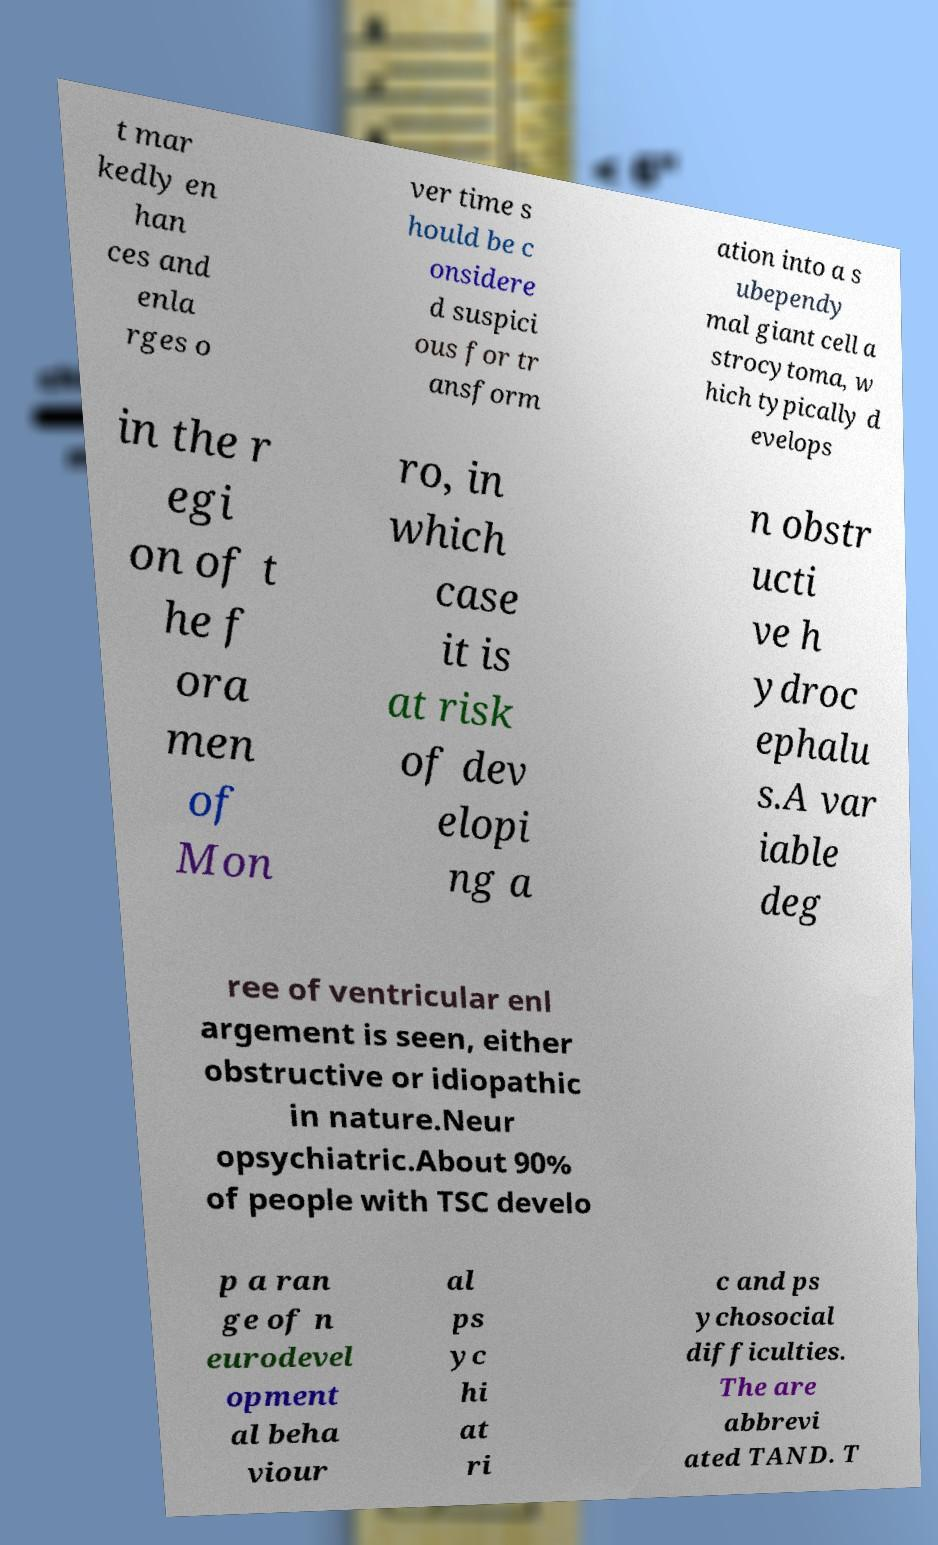Can you read and provide the text displayed in the image?This photo seems to have some interesting text. Can you extract and type it out for me? t mar kedly en han ces and enla rges o ver time s hould be c onsidere d suspici ous for tr ansform ation into a s ubependy mal giant cell a strocytoma, w hich typically d evelops in the r egi on of t he f ora men of Mon ro, in which case it is at risk of dev elopi ng a n obstr ucti ve h ydroc ephalu s.A var iable deg ree of ventricular enl argement is seen, either obstructive or idiopathic in nature.Neur opsychiatric.About 90% of people with TSC develo p a ran ge of n eurodevel opment al beha viour al ps yc hi at ri c and ps ychosocial difficulties. The are abbrevi ated TAND. T 